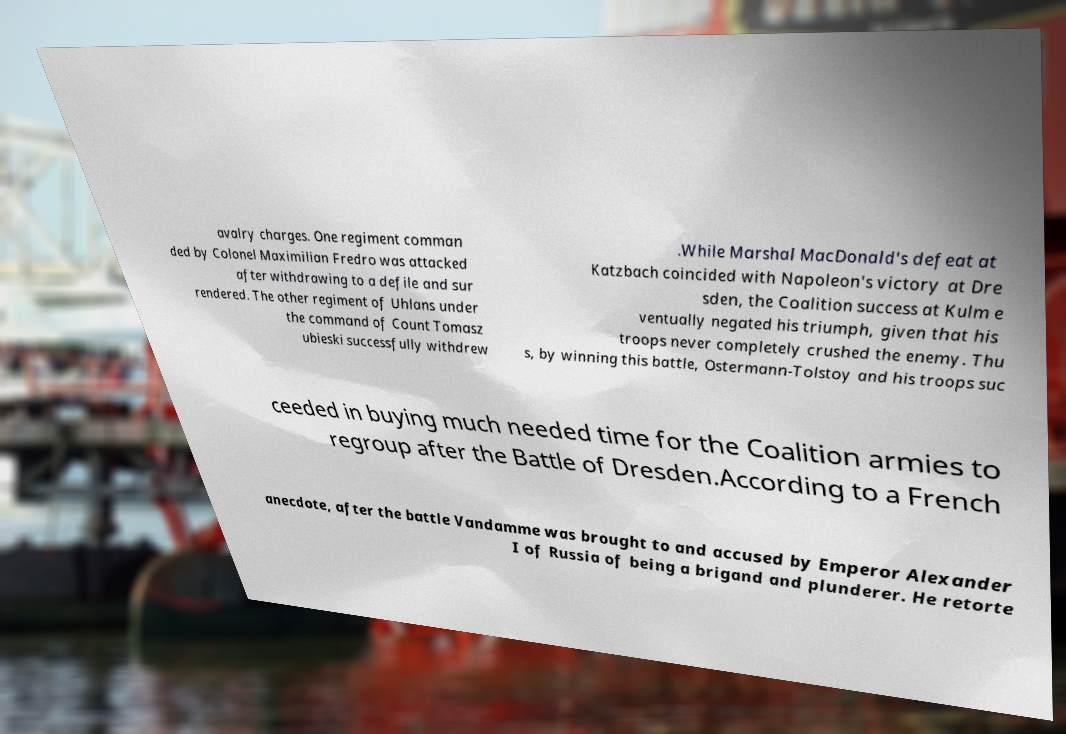I need the written content from this picture converted into text. Can you do that? avalry charges. One regiment comman ded by Colonel Maximilian Fredro was attacked after withdrawing to a defile and sur rendered. The other regiment of Uhlans under the command of Count Tomasz ubieski successfully withdrew .While Marshal MacDonald's defeat at Katzbach coincided with Napoleon's victory at Dre sden, the Coalition success at Kulm e ventually negated his triumph, given that his troops never completely crushed the enemy. Thu s, by winning this battle, Ostermann-Tolstoy and his troops suc ceeded in buying much needed time for the Coalition armies to regroup after the Battle of Dresden.According to a French anecdote, after the battle Vandamme was brought to and accused by Emperor Alexander I of Russia of being a brigand and plunderer. He retorte 